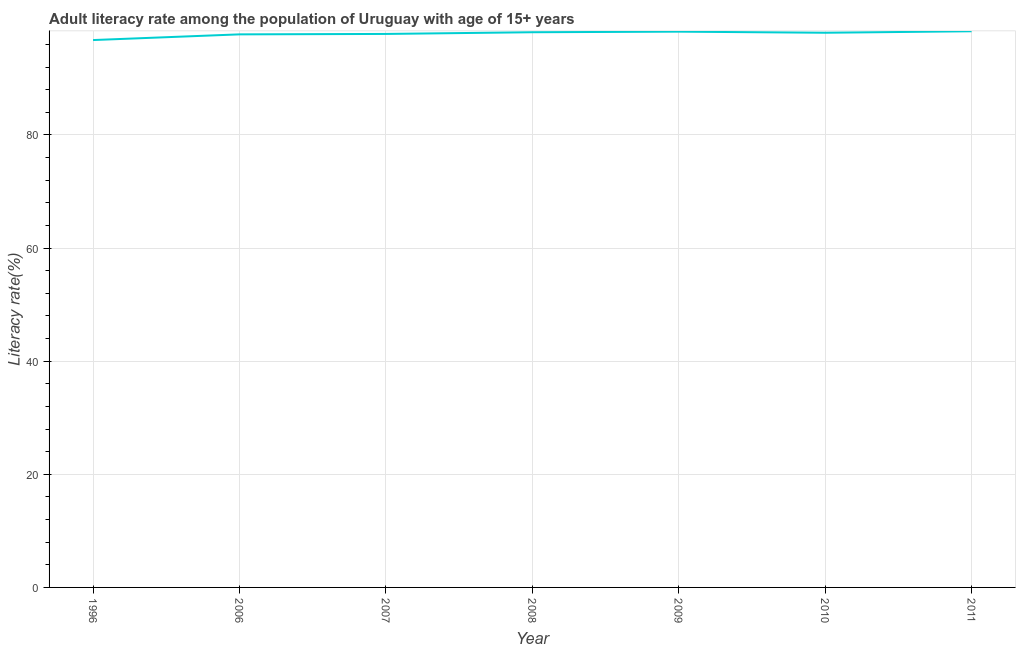What is the adult literacy rate in 2007?
Provide a short and direct response. 97.86. Across all years, what is the maximum adult literacy rate?
Your answer should be very brief. 98.34. Across all years, what is the minimum adult literacy rate?
Keep it short and to the point. 96.78. In which year was the adult literacy rate maximum?
Make the answer very short. 2011. In which year was the adult literacy rate minimum?
Your response must be concise. 1996. What is the sum of the adult literacy rate?
Your response must be concise. 685.28. What is the difference between the adult literacy rate in 1996 and 2011?
Your answer should be very brief. -1.55. What is the average adult literacy rate per year?
Offer a very short reply. 97.9. What is the median adult literacy rate?
Ensure brevity in your answer.  98.07. What is the ratio of the adult literacy rate in 2010 to that in 2011?
Your answer should be compact. 1. Is the adult literacy rate in 1996 less than that in 2006?
Provide a short and direct response. Yes. What is the difference between the highest and the second highest adult literacy rate?
Your answer should be compact. 0.07. Is the sum of the adult literacy rate in 1996 and 2006 greater than the maximum adult literacy rate across all years?
Offer a very short reply. Yes. What is the difference between the highest and the lowest adult literacy rate?
Your response must be concise. 1.55. In how many years, is the adult literacy rate greater than the average adult literacy rate taken over all years?
Provide a short and direct response. 4. How many years are there in the graph?
Offer a very short reply. 7. Does the graph contain any zero values?
Provide a succinct answer. No. What is the title of the graph?
Provide a succinct answer. Adult literacy rate among the population of Uruguay with age of 15+ years. What is the label or title of the X-axis?
Your answer should be very brief. Year. What is the label or title of the Y-axis?
Make the answer very short. Literacy rate(%). What is the Literacy rate(%) of 1996?
Keep it short and to the point. 96.78. What is the Literacy rate(%) of 2006?
Make the answer very short. 97.79. What is the Literacy rate(%) of 2007?
Offer a terse response. 97.86. What is the Literacy rate(%) of 2008?
Your response must be concise. 98.16. What is the Literacy rate(%) in 2009?
Provide a short and direct response. 98.27. What is the Literacy rate(%) in 2010?
Your answer should be compact. 98.07. What is the Literacy rate(%) in 2011?
Provide a short and direct response. 98.34. What is the difference between the Literacy rate(%) in 1996 and 2006?
Your response must be concise. -1.01. What is the difference between the Literacy rate(%) in 1996 and 2007?
Provide a short and direct response. -1.08. What is the difference between the Literacy rate(%) in 1996 and 2008?
Your response must be concise. -1.38. What is the difference between the Literacy rate(%) in 1996 and 2009?
Your answer should be compact. -1.49. What is the difference between the Literacy rate(%) in 1996 and 2010?
Provide a succinct answer. -1.29. What is the difference between the Literacy rate(%) in 1996 and 2011?
Your answer should be very brief. -1.55. What is the difference between the Literacy rate(%) in 2006 and 2007?
Keep it short and to the point. -0.07. What is the difference between the Literacy rate(%) in 2006 and 2008?
Your response must be concise. -0.37. What is the difference between the Literacy rate(%) in 2006 and 2009?
Make the answer very short. -0.48. What is the difference between the Literacy rate(%) in 2006 and 2010?
Provide a succinct answer. -0.28. What is the difference between the Literacy rate(%) in 2006 and 2011?
Offer a very short reply. -0.55. What is the difference between the Literacy rate(%) in 2007 and 2008?
Make the answer very short. -0.3. What is the difference between the Literacy rate(%) in 2007 and 2009?
Keep it short and to the point. -0.4. What is the difference between the Literacy rate(%) in 2007 and 2010?
Your response must be concise. -0.21. What is the difference between the Literacy rate(%) in 2007 and 2011?
Provide a succinct answer. -0.47. What is the difference between the Literacy rate(%) in 2008 and 2009?
Your answer should be compact. -0.1. What is the difference between the Literacy rate(%) in 2008 and 2010?
Provide a short and direct response. 0.09. What is the difference between the Literacy rate(%) in 2008 and 2011?
Provide a succinct answer. -0.17. What is the difference between the Literacy rate(%) in 2009 and 2010?
Make the answer very short. 0.2. What is the difference between the Literacy rate(%) in 2009 and 2011?
Give a very brief answer. -0.07. What is the difference between the Literacy rate(%) in 2010 and 2011?
Give a very brief answer. -0.26. What is the ratio of the Literacy rate(%) in 1996 to that in 2006?
Give a very brief answer. 0.99. What is the ratio of the Literacy rate(%) in 1996 to that in 2008?
Provide a short and direct response. 0.99. What is the ratio of the Literacy rate(%) in 1996 to that in 2010?
Make the answer very short. 0.99. What is the ratio of the Literacy rate(%) in 1996 to that in 2011?
Give a very brief answer. 0.98. What is the ratio of the Literacy rate(%) in 2006 to that in 2007?
Keep it short and to the point. 1. What is the ratio of the Literacy rate(%) in 2006 to that in 2011?
Make the answer very short. 0.99. What is the ratio of the Literacy rate(%) in 2007 to that in 2011?
Provide a succinct answer. 0.99. What is the ratio of the Literacy rate(%) in 2008 to that in 2010?
Provide a succinct answer. 1. What is the ratio of the Literacy rate(%) in 2008 to that in 2011?
Your answer should be very brief. 1. What is the ratio of the Literacy rate(%) in 2009 to that in 2010?
Provide a succinct answer. 1. What is the ratio of the Literacy rate(%) in 2009 to that in 2011?
Make the answer very short. 1. 